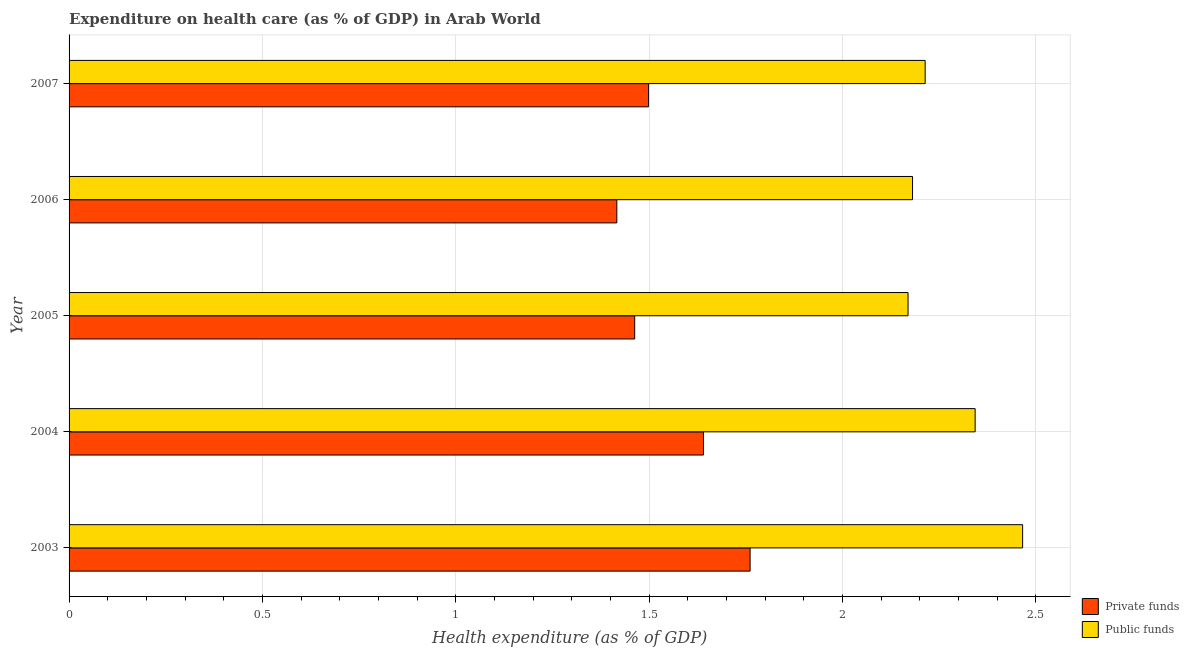Are the number of bars per tick equal to the number of legend labels?
Give a very brief answer. Yes. Are the number of bars on each tick of the Y-axis equal?
Offer a terse response. Yes. How many bars are there on the 3rd tick from the top?
Your answer should be compact. 2. What is the amount of public funds spent in healthcare in 2003?
Provide a short and direct response. 2.47. Across all years, what is the maximum amount of public funds spent in healthcare?
Ensure brevity in your answer.  2.47. Across all years, what is the minimum amount of private funds spent in healthcare?
Ensure brevity in your answer.  1.42. In which year was the amount of private funds spent in healthcare maximum?
Provide a succinct answer. 2003. In which year was the amount of public funds spent in healthcare minimum?
Your answer should be very brief. 2005. What is the total amount of public funds spent in healthcare in the graph?
Ensure brevity in your answer.  11.37. What is the difference between the amount of private funds spent in healthcare in 2004 and that in 2005?
Ensure brevity in your answer.  0.18. What is the difference between the amount of public funds spent in healthcare in 2007 and the amount of private funds spent in healthcare in 2005?
Provide a short and direct response. 0.75. What is the average amount of public funds spent in healthcare per year?
Provide a succinct answer. 2.27. In the year 2007, what is the difference between the amount of private funds spent in healthcare and amount of public funds spent in healthcare?
Offer a very short reply. -0.71. In how many years, is the amount of private funds spent in healthcare greater than 1.1 %?
Offer a very short reply. 5. What is the ratio of the amount of private funds spent in healthcare in 2004 to that in 2005?
Ensure brevity in your answer.  1.12. What is the difference between the highest and the second highest amount of public funds spent in healthcare?
Offer a very short reply. 0.12. What is the difference between the highest and the lowest amount of public funds spent in healthcare?
Offer a very short reply. 0.3. In how many years, is the amount of private funds spent in healthcare greater than the average amount of private funds spent in healthcare taken over all years?
Give a very brief answer. 2. Is the sum of the amount of public funds spent in healthcare in 2004 and 2005 greater than the maximum amount of private funds spent in healthcare across all years?
Provide a short and direct response. Yes. What does the 2nd bar from the top in 2005 represents?
Your answer should be compact. Private funds. What does the 1st bar from the bottom in 2004 represents?
Your response must be concise. Private funds. Are all the bars in the graph horizontal?
Make the answer very short. Yes. How many years are there in the graph?
Give a very brief answer. 5. Does the graph contain grids?
Your response must be concise. Yes. How many legend labels are there?
Keep it short and to the point. 2. How are the legend labels stacked?
Your answer should be compact. Vertical. What is the title of the graph?
Provide a succinct answer. Expenditure on health care (as % of GDP) in Arab World. What is the label or title of the X-axis?
Offer a very short reply. Health expenditure (as % of GDP). What is the Health expenditure (as % of GDP) in Private funds in 2003?
Provide a short and direct response. 1.76. What is the Health expenditure (as % of GDP) of Public funds in 2003?
Make the answer very short. 2.47. What is the Health expenditure (as % of GDP) in Private funds in 2004?
Provide a succinct answer. 1.64. What is the Health expenditure (as % of GDP) of Public funds in 2004?
Keep it short and to the point. 2.34. What is the Health expenditure (as % of GDP) in Private funds in 2005?
Your response must be concise. 1.46. What is the Health expenditure (as % of GDP) in Public funds in 2005?
Ensure brevity in your answer.  2.17. What is the Health expenditure (as % of GDP) in Private funds in 2006?
Provide a succinct answer. 1.42. What is the Health expenditure (as % of GDP) in Public funds in 2006?
Provide a succinct answer. 2.18. What is the Health expenditure (as % of GDP) of Private funds in 2007?
Offer a terse response. 1.5. What is the Health expenditure (as % of GDP) in Public funds in 2007?
Provide a succinct answer. 2.21. Across all years, what is the maximum Health expenditure (as % of GDP) of Private funds?
Offer a very short reply. 1.76. Across all years, what is the maximum Health expenditure (as % of GDP) in Public funds?
Ensure brevity in your answer.  2.47. Across all years, what is the minimum Health expenditure (as % of GDP) of Private funds?
Provide a succinct answer. 1.42. Across all years, what is the minimum Health expenditure (as % of GDP) of Public funds?
Keep it short and to the point. 2.17. What is the total Health expenditure (as % of GDP) in Private funds in the graph?
Make the answer very short. 7.78. What is the total Health expenditure (as % of GDP) of Public funds in the graph?
Keep it short and to the point. 11.37. What is the difference between the Health expenditure (as % of GDP) of Private funds in 2003 and that in 2004?
Your answer should be compact. 0.12. What is the difference between the Health expenditure (as % of GDP) of Public funds in 2003 and that in 2004?
Keep it short and to the point. 0.12. What is the difference between the Health expenditure (as % of GDP) of Private funds in 2003 and that in 2005?
Offer a terse response. 0.3. What is the difference between the Health expenditure (as % of GDP) in Public funds in 2003 and that in 2005?
Make the answer very short. 0.3. What is the difference between the Health expenditure (as % of GDP) in Private funds in 2003 and that in 2006?
Your answer should be very brief. 0.34. What is the difference between the Health expenditure (as % of GDP) in Public funds in 2003 and that in 2006?
Give a very brief answer. 0.28. What is the difference between the Health expenditure (as % of GDP) in Private funds in 2003 and that in 2007?
Give a very brief answer. 0.26. What is the difference between the Health expenditure (as % of GDP) in Public funds in 2003 and that in 2007?
Ensure brevity in your answer.  0.25. What is the difference between the Health expenditure (as % of GDP) of Private funds in 2004 and that in 2005?
Provide a short and direct response. 0.18. What is the difference between the Health expenditure (as % of GDP) of Public funds in 2004 and that in 2005?
Your answer should be compact. 0.17. What is the difference between the Health expenditure (as % of GDP) of Private funds in 2004 and that in 2006?
Offer a very short reply. 0.22. What is the difference between the Health expenditure (as % of GDP) in Public funds in 2004 and that in 2006?
Make the answer very short. 0.16. What is the difference between the Health expenditure (as % of GDP) in Private funds in 2004 and that in 2007?
Keep it short and to the point. 0.14. What is the difference between the Health expenditure (as % of GDP) in Public funds in 2004 and that in 2007?
Offer a terse response. 0.13. What is the difference between the Health expenditure (as % of GDP) of Private funds in 2005 and that in 2006?
Keep it short and to the point. 0.05. What is the difference between the Health expenditure (as % of GDP) in Public funds in 2005 and that in 2006?
Keep it short and to the point. -0.01. What is the difference between the Health expenditure (as % of GDP) in Private funds in 2005 and that in 2007?
Give a very brief answer. -0.04. What is the difference between the Health expenditure (as % of GDP) of Public funds in 2005 and that in 2007?
Keep it short and to the point. -0.04. What is the difference between the Health expenditure (as % of GDP) in Private funds in 2006 and that in 2007?
Offer a very short reply. -0.08. What is the difference between the Health expenditure (as % of GDP) in Public funds in 2006 and that in 2007?
Keep it short and to the point. -0.03. What is the difference between the Health expenditure (as % of GDP) in Private funds in 2003 and the Health expenditure (as % of GDP) in Public funds in 2004?
Provide a succinct answer. -0.58. What is the difference between the Health expenditure (as % of GDP) of Private funds in 2003 and the Health expenditure (as % of GDP) of Public funds in 2005?
Provide a short and direct response. -0.41. What is the difference between the Health expenditure (as % of GDP) in Private funds in 2003 and the Health expenditure (as % of GDP) in Public funds in 2006?
Give a very brief answer. -0.42. What is the difference between the Health expenditure (as % of GDP) of Private funds in 2003 and the Health expenditure (as % of GDP) of Public funds in 2007?
Give a very brief answer. -0.45. What is the difference between the Health expenditure (as % of GDP) in Private funds in 2004 and the Health expenditure (as % of GDP) in Public funds in 2005?
Your answer should be very brief. -0.53. What is the difference between the Health expenditure (as % of GDP) of Private funds in 2004 and the Health expenditure (as % of GDP) of Public funds in 2006?
Your response must be concise. -0.54. What is the difference between the Health expenditure (as % of GDP) of Private funds in 2004 and the Health expenditure (as % of GDP) of Public funds in 2007?
Provide a succinct answer. -0.57. What is the difference between the Health expenditure (as % of GDP) in Private funds in 2005 and the Health expenditure (as % of GDP) in Public funds in 2006?
Your response must be concise. -0.72. What is the difference between the Health expenditure (as % of GDP) in Private funds in 2005 and the Health expenditure (as % of GDP) in Public funds in 2007?
Ensure brevity in your answer.  -0.75. What is the difference between the Health expenditure (as % of GDP) of Private funds in 2006 and the Health expenditure (as % of GDP) of Public funds in 2007?
Ensure brevity in your answer.  -0.8. What is the average Health expenditure (as % of GDP) of Private funds per year?
Your answer should be very brief. 1.56. What is the average Health expenditure (as % of GDP) of Public funds per year?
Provide a short and direct response. 2.27. In the year 2003, what is the difference between the Health expenditure (as % of GDP) of Private funds and Health expenditure (as % of GDP) of Public funds?
Keep it short and to the point. -0.7. In the year 2004, what is the difference between the Health expenditure (as % of GDP) in Private funds and Health expenditure (as % of GDP) in Public funds?
Your answer should be very brief. -0.7. In the year 2005, what is the difference between the Health expenditure (as % of GDP) in Private funds and Health expenditure (as % of GDP) in Public funds?
Provide a short and direct response. -0.71. In the year 2006, what is the difference between the Health expenditure (as % of GDP) in Private funds and Health expenditure (as % of GDP) in Public funds?
Provide a succinct answer. -0.76. In the year 2007, what is the difference between the Health expenditure (as % of GDP) in Private funds and Health expenditure (as % of GDP) in Public funds?
Keep it short and to the point. -0.72. What is the ratio of the Health expenditure (as % of GDP) in Private funds in 2003 to that in 2004?
Your answer should be very brief. 1.07. What is the ratio of the Health expenditure (as % of GDP) of Public funds in 2003 to that in 2004?
Provide a short and direct response. 1.05. What is the ratio of the Health expenditure (as % of GDP) in Private funds in 2003 to that in 2005?
Offer a very short reply. 1.2. What is the ratio of the Health expenditure (as % of GDP) in Public funds in 2003 to that in 2005?
Give a very brief answer. 1.14. What is the ratio of the Health expenditure (as % of GDP) of Private funds in 2003 to that in 2006?
Provide a succinct answer. 1.24. What is the ratio of the Health expenditure (as % of GDP) in Public funds in 2003 to that in 2006?
Offer a very short reply. 1.13. What is the ratio of the Health expenditure (as % of GDP) in Private funds in 2003 to that in 2007?
Make the answer very short. 1.18. What is the ratio of the Health expenditure (as % of GDP) of Public funds in 2003 to that in 2007?
Provide a succinct answer. 1.11. What is the ratio of the Health expenditure (as % of GDP) of Private funds in 2004 to that in 2005?
Your answer should be very brief. 1.12. What is the ratio of the Health expenditure (as % of GDP) in Public funds in 2004 to that in 2005?
Ensure brevity in your answer.  1.08. What is the ratio of the Health expenditure (as % of GDP) in Private funds in 2004 to that in 2006?
Your answer should be very brief. 1.16. What is the ratio of the Health expenditure (as % of GDP) of Public funds in 2004 to that in 2006?
Keep it short and to the point. 1.07. What is the ratio of the Health expenditure (as % of GDP) of Private funds in 2004 to that in 2007?
Your answer should be compact. 1.09. What is the ratio of the Health expenditure (as % of GDP) of Public funds in 2004 to that in 2007?
Your answer should be compact. 1.06. What is the ratio of the Health expenditure (as % of GDP) of Private funds in 2005 to that in 2006?
Provide a short and direct response. 1.03. What is the ratio of the Health expenditure (as % of GDP) in Private funds in 2005 to that in 2007?
Ensure brevity in your answer.  0.98. What is the ratio of the Health expenditure (as % of GDP) in Private funds in 2006 to that in 2007?
Your answer should be very brief. 0.95. What is the ratio of the Health expenditure (as % of GDP) in Public funds in 2006 to that in 2007?
Keep it short and to the point. 0.99. What is the difference between the highest and the second highest Health expenditure (as % of GDP) of Private funds?
Offer a terse response. 0.12. What is the difference between the highest and the second highest Health expenditure (as % of GDP) of Public funds?
Provide a succinct answer. 0.12. What is the difference between the highest and the lowest Health expenditure (as % of GDP) in Private funds?
Provide a succinct answer. 0.34. What is the difference between the highest and the lowest Health expenditure (as % of GDP) in Public funds?
Offer a very short reply. 0.3. 